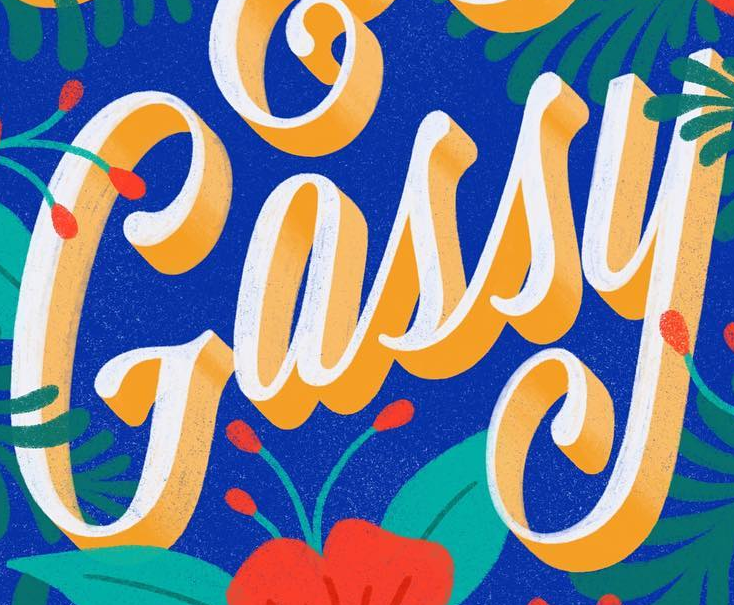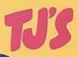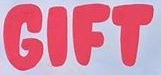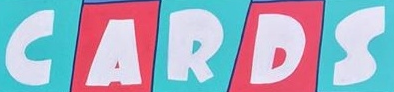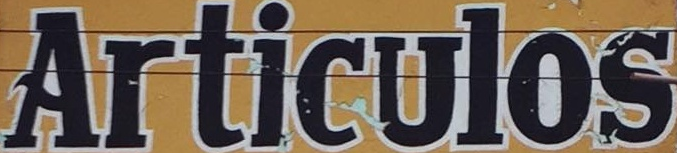Transcribe the words shown in these images in order, separated by a semicolon. Gassy; TJ'S; GIFT; CARDS; Articulos 